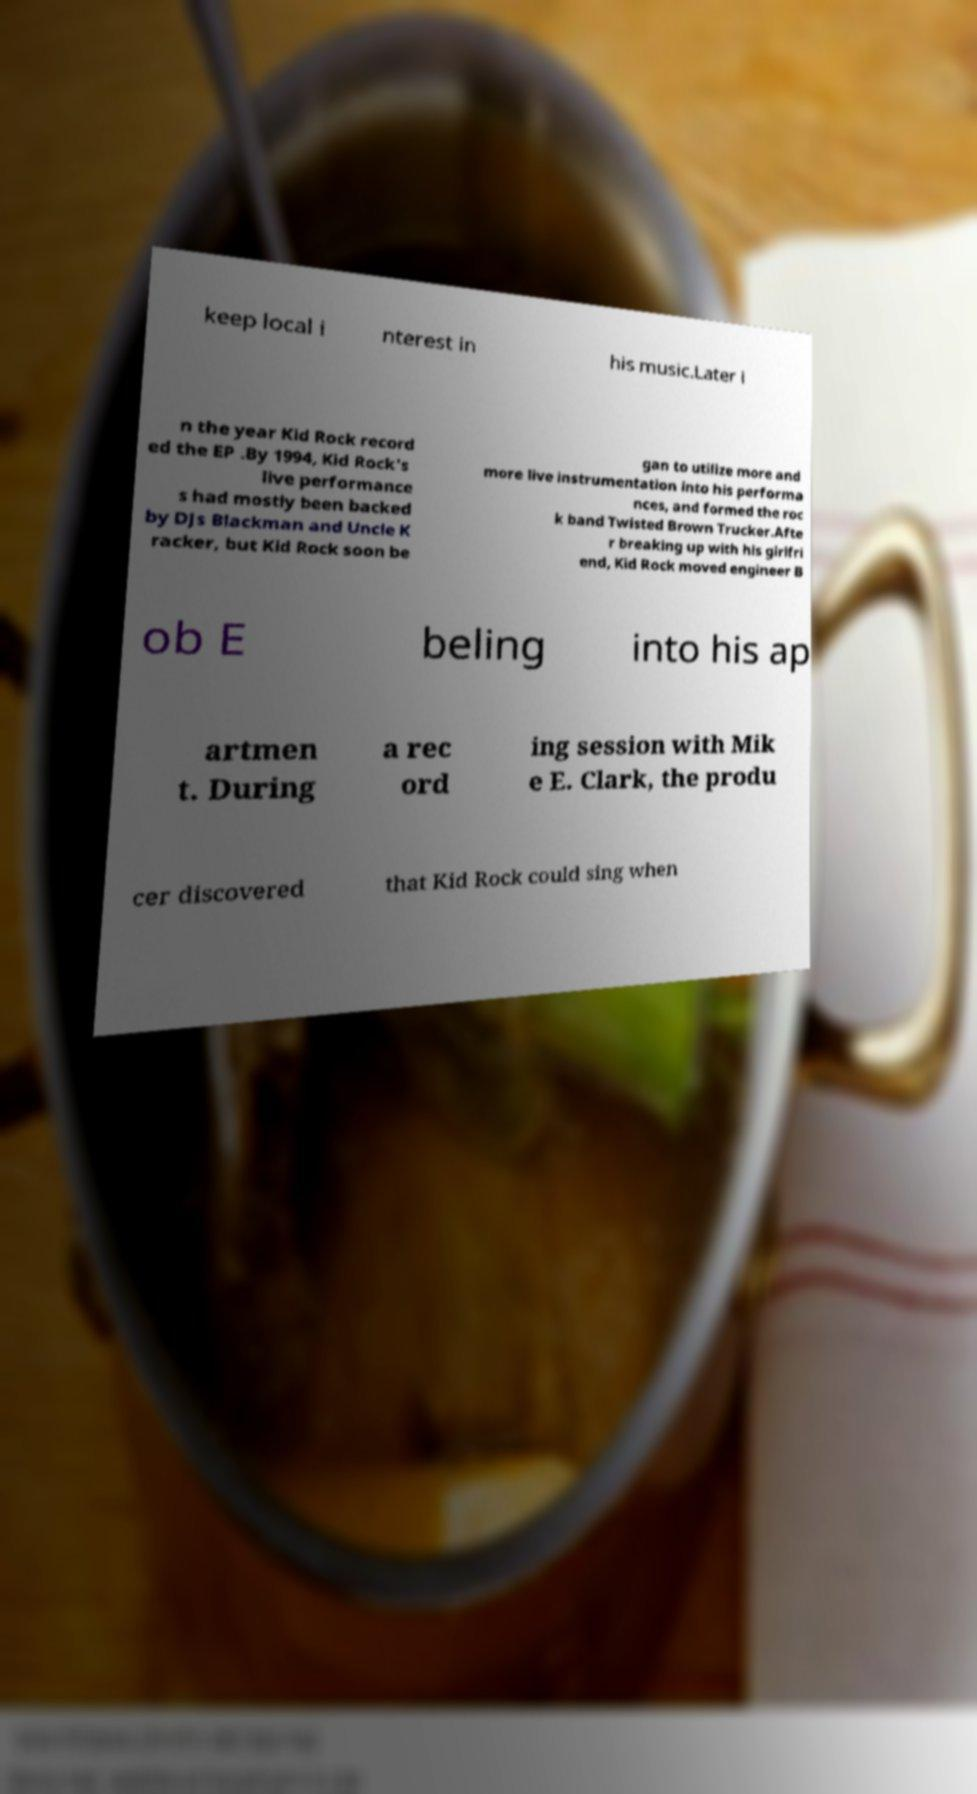What messages or text are displayed in this image? I need them in a readable, typed format. keep local i nterest in his music.Later i n the year Kid Rock record ed the EP .By 1994, Kid Rock's live performance s had mostly been backed by DJs Blackman and Uncle K racker, but Kid Rock soon be gan to utilize more and more live instrumentation into his performa nces, and formed the roc k band Twisted Brown Trucker.Afte r breaking up with his girlfri end, Kid Rock moved engineer B ob E beling into his ap artmen t. During a rec ord ing session with Mik e E. Clark, the produ cer discovered that Kid Rock could sing when 